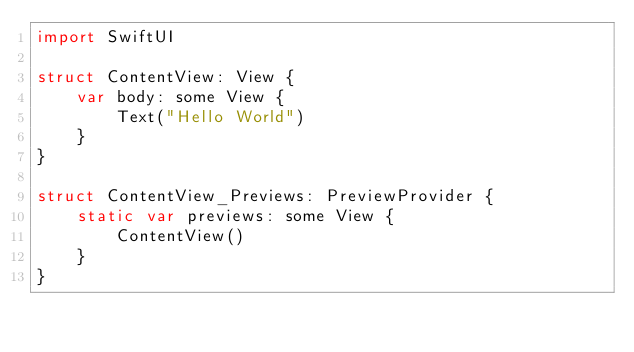Convert code to text. <code><loc_0><loc_0><loc_500><loc_500><_Swift_>import SwiftUI

struct ContentView: View {
    var body: some View {
        Text("Hello World")
    }
}

struct ContentView_Previews: PreviewProvider {
    static var previews: some View {
        ContentView()
    }
}

</code> 